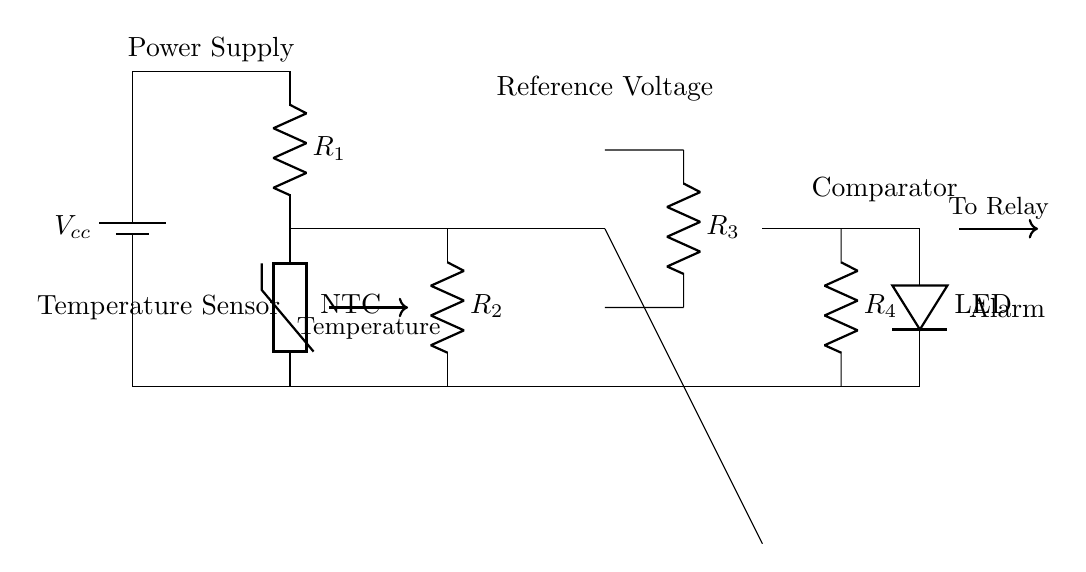What is the power supply voltage of this circuit? The power supply voltage is at the top of the circuit, marked as Vcc. It is the source providing power to the components.
Answer: Vcc What type of temperature sensor is used in this circuit? The temperature sensor is indicated as a thermistor, specifically a negative temperature coefficient (NTC) thermistor, which decreases in resistance as temperature increases.
Answer: NTC How many resistors are present in the circuit? The circuit shows a total of four resistors, labeled as R1, R2, R3, and R4, all of which are connected in different parts of the circuit.
Answer: Four What does the LED indicate in the circuit? The LED is connected at the output of the comparator; it serves as an alarm to indicate when the temperature exceeds a certain threshold.
Answer: Alarm At which point in the circuit is the comparator located? The comparator is located between the reference voltage and the output to the LED. It compares the voltage from the thermistor with the reference voltage to determine if the alarm should activate.
Answer: Between reference voltage and LED What happens when the temperature exceeds a certain limit? When the temperature exceeds a pre-defined threshold, the comparator switches, activating the LED to signal a temperature alert and potentially triggering a relay for further action.
Answer: LED lights up What role does R4 play in the circuit? R4 acts as a pull-down resistor connected between the output of the comparator and ground, ensuring the LED has a defined state when the comparator output is low, thereby stabilizing the circuit's performance.
Answer: Stabilizes circuit 